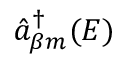<formula> <loc_0><loc_0><loc_500><loc_500>\hat { a } _ { \beta m } ^ { \dagger } ( E )</formula> 